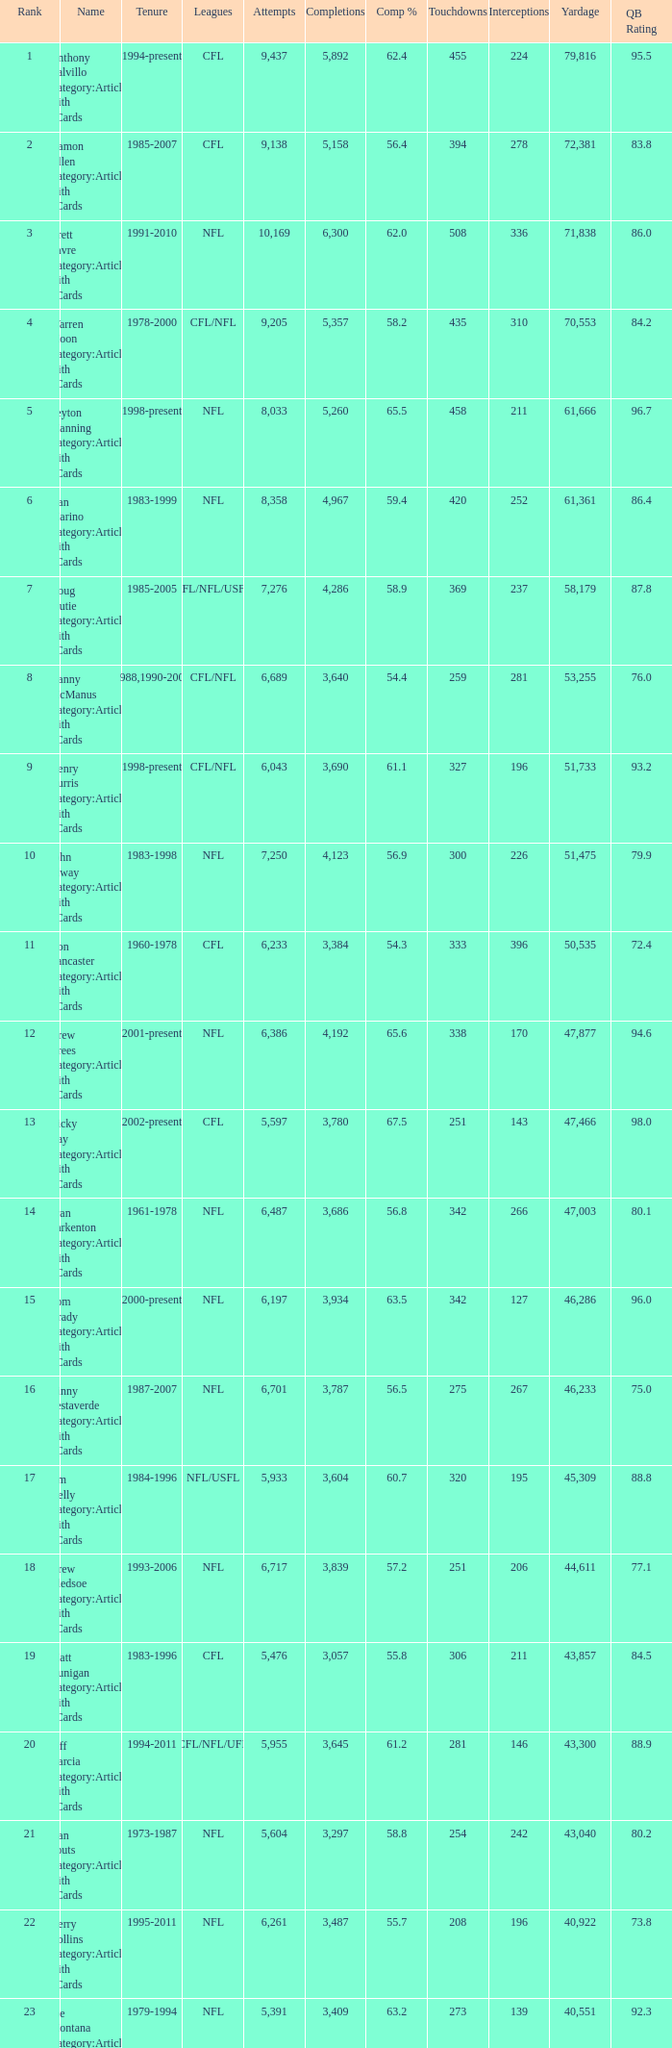How many interceptions are there with fewer than 3,487 completions, over 40,551 yards, and a 55.8% completion percentage? 211.0. 